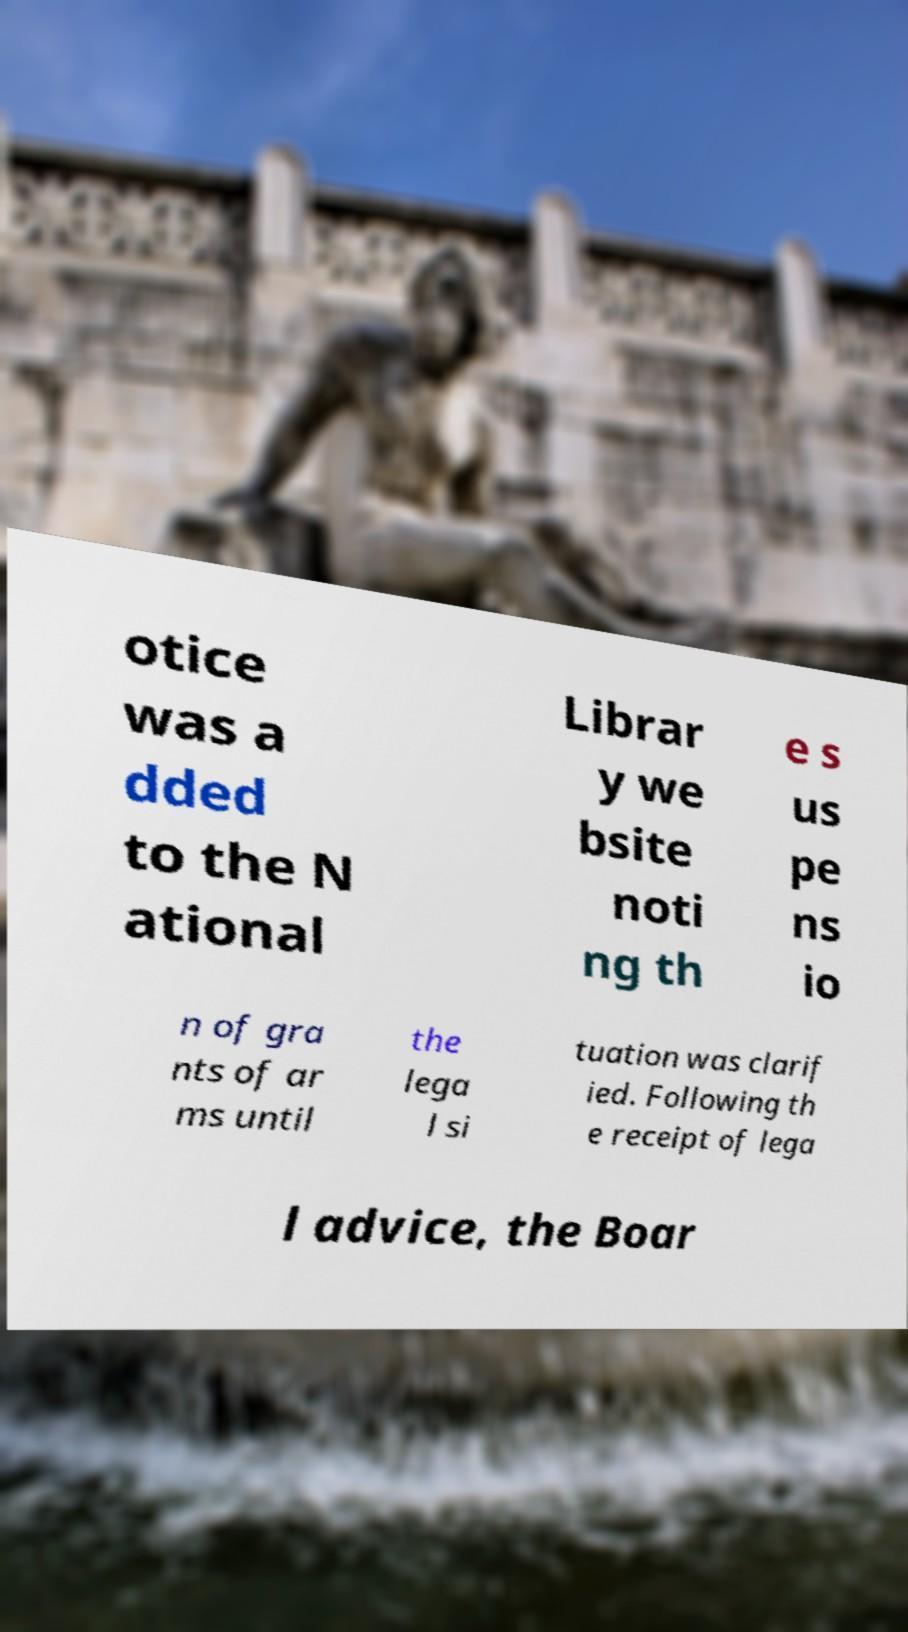Can you accurately transcribe the text from the provided image for me? otice was a dded to the N ational Librar y we bsite noti ng th e s us pe ns io n of gra nts of ar ms until the lega l si tuation was clarif ied. Following th e receipt of lega l advice, the Boar 